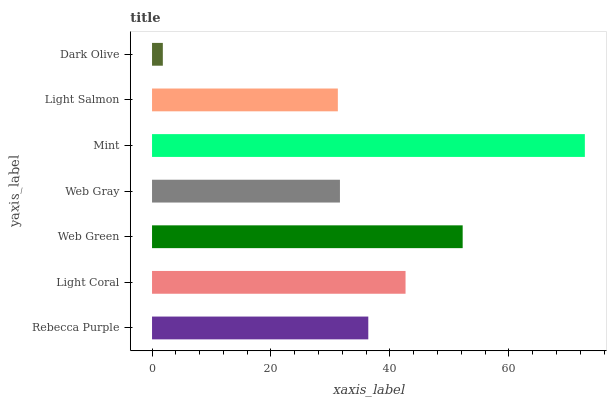Is Dark Olive the minimum?
Answer yes or no. Yes. Is Mint the maximum?
Answer yes or no. Yes. Is Light Coral the minimum?
Answer yes or no. No. Is Light Coral the maximum?
Answer yes or no. No. Is Light Coral greater than Rebecca Purple?
Answer yes or no. Yes. Is Rebecca Purple less than Light Coral?
Answer yes or no. Yes. Is Rebecca Purple greater than Light Coral?
Answer yes or no. No. Is Light Coral less than Rebecca Purple?
Answer yes or no. No. Is Rebecca Purple the high median?
Answer yes or no. Yes. Is Rebecca Purple the low median?
Answer yes or no. Yes. Is Web Green the high median?
Answer yes or no. No. Is Mint the low median?
Answer yes or no. No. 